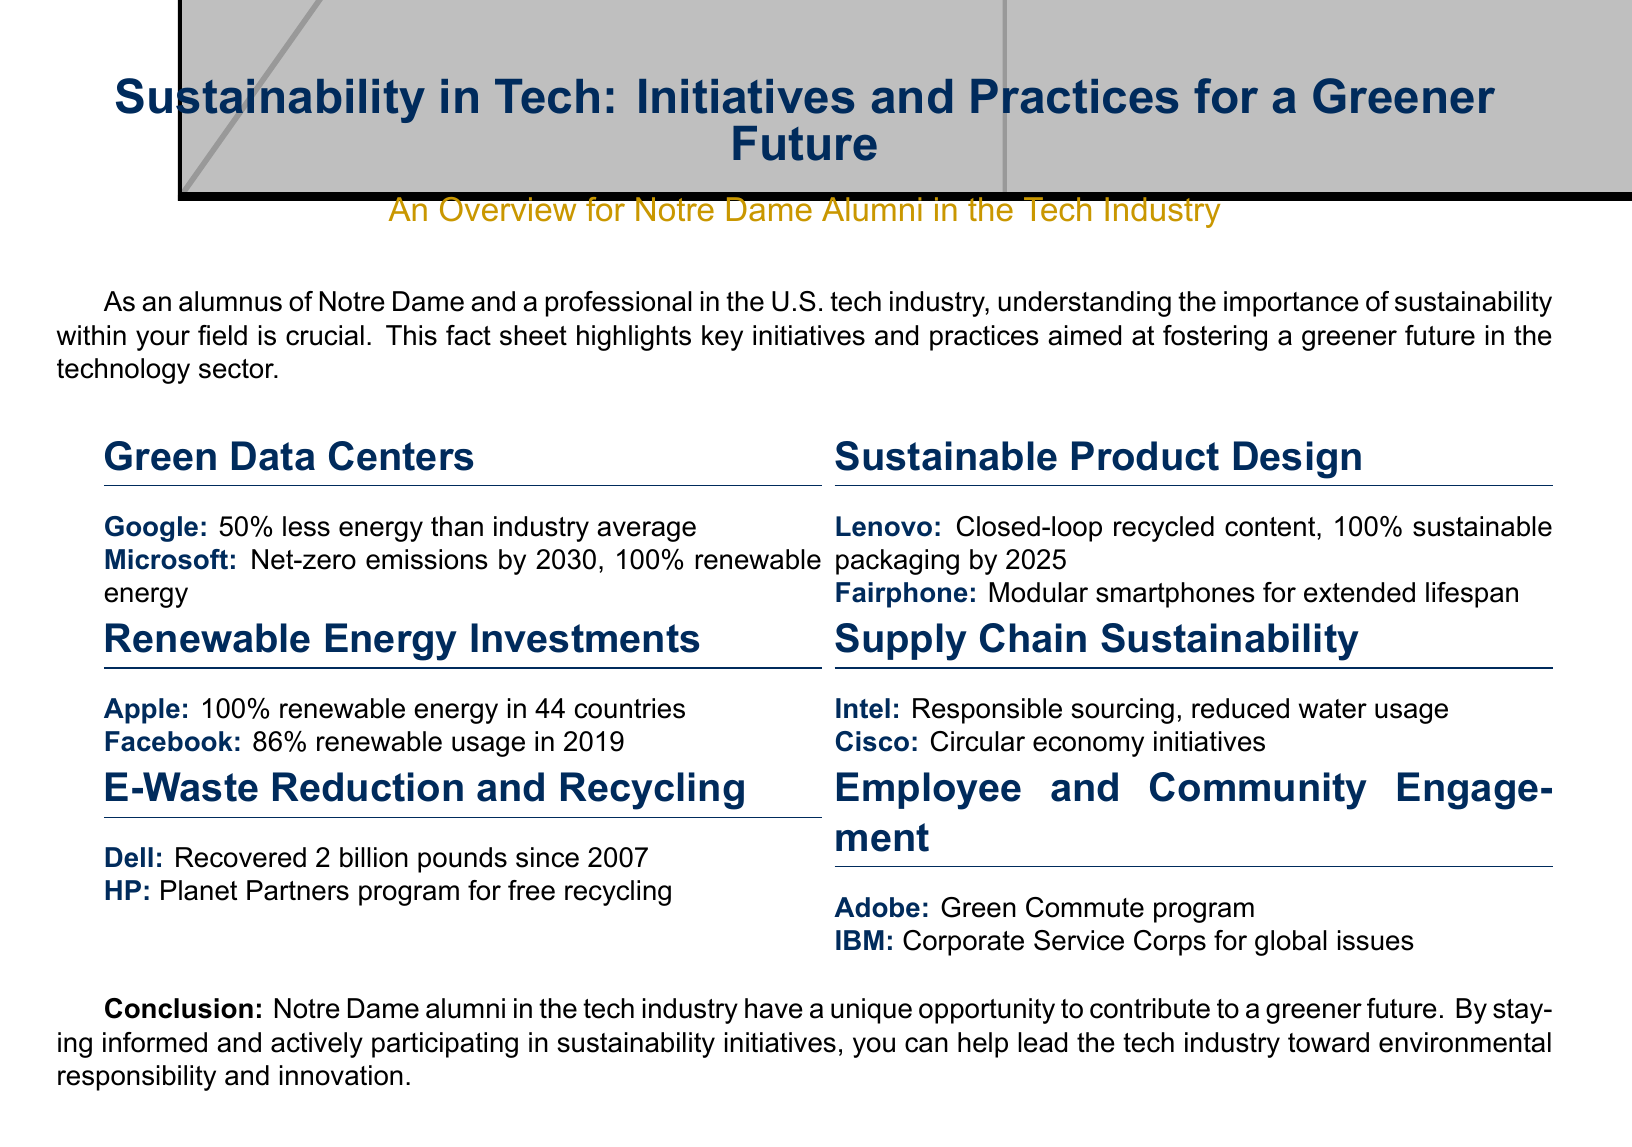What percentage less energy does Google use compared to the industry average? The document states that Google uses 50% less energy than the industry average.
Answer: 50% What year is Microsoft aiming for net-zero emissions? The document mentions that Microsoft aims for net-zero emissions by 2030.
Answer: 2030 How many pounds has Dell recovered since 2007? The document indicates Dell has recovered 2 billion pounds since 2007.
Answer: 2 billion pounds What is the sustainability target for Lenovo's packaging by 2025? Lenovo has a target of 100% sustainable packaging by 2025.
Answer: 100% sustainable packaging by 2025 What program does Adobe implement for employee engagement? The document specifies Adobe's Green Commute program as their initiative for employee engagement.
Answer: Green Commute program Which company has 86% renewable energy usage in 2019? The document states that Facebook had 86% renewable energy usage in 2019.
Answer: Facebook What initiative does HP offer for e-waste? According to the document, HP has the Planet Partners program for free recycling.
Answer: Planet Partners program How does Intel promote supply chain sustainability? Intel promotes responsible sourcing and reduced water usage as part of supply chain sustainability.
Answer: Responsible sourcing, reduced water usage What unique opportunity do Notre Dame alumni have according to the conclusion? The conclusion suggests that Notre Dame alumni have a unique opportunity to contribute to a greener future through sustainability initiatives.
Answer: Contribute to a greener future 